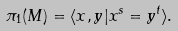<formula> <loc_0><loc_0><loc_500><loc_500>\pi _ { 1 } ( M ) = \langle x , y | x ^ { s } = y ^ { t } \rangle .</formula> 